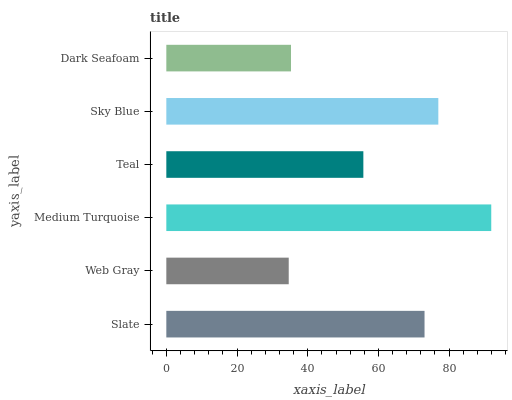Is Web Gray the minimum?
Answer yes or no. Yes. Is Medium Turquoise the maximum?
Answer yes or no. Yes. Is Medium Turquoise the minimum?
Answer yes or no. No. Is Web Gray the maximum?
Answer yes or no. No. Is Medium Turquoise greater than Web Gray?
Answer yes or no. Yes. Is Web Gray less than Medium Turquoise?
Answer yes or no. Yes. Is Web Gray greater than Medium Turquoise?
Answer yes or no. No. Is Medium Turquoise less than Web Gray?
Answer yes or no. No. Is Slate the high median?
Answer yes or no. Yes. Is Teal the low median?
Answer yes or no. Yes. Is Sky Blue the high median?
Answer yes or no. No. Is Dark Seafoam the low median?
Answer yes or no. No. 